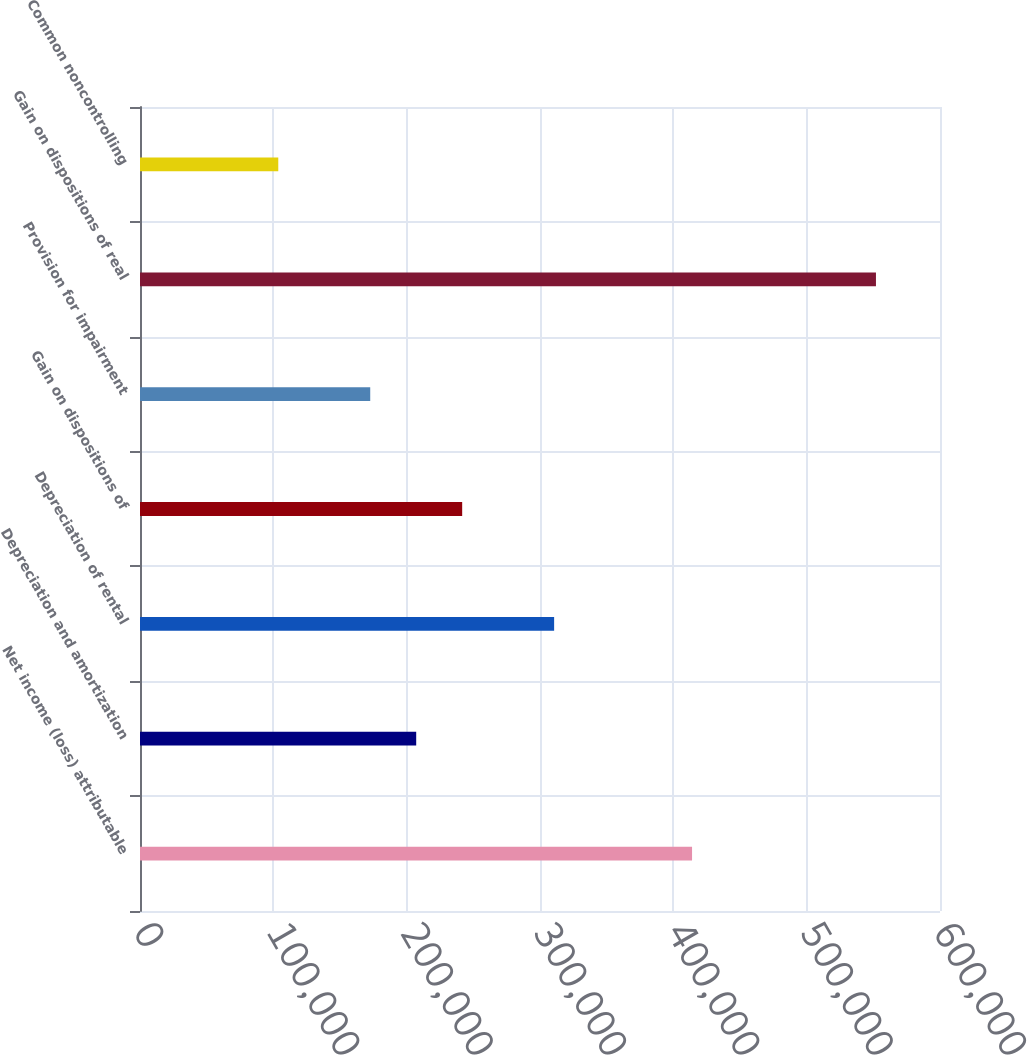Convert chart. <chart><loc_0><loc_0><loc_500><loc_500><bar_chart><fcel>Net income (loss) attributable<fcel>Depreciation and amortization<fcel>Depreciation of rental<fcel>Gain on dispositions of<fcel>Provision for impairment<fcel>Gain on dispositions of real<fcel>Common noncontrolling<nl><fcel>414040<fcel>207152<fcel>310596<fcel>241633<fcel>172670<fcel>551965<fcel>103708<nl></chart> 